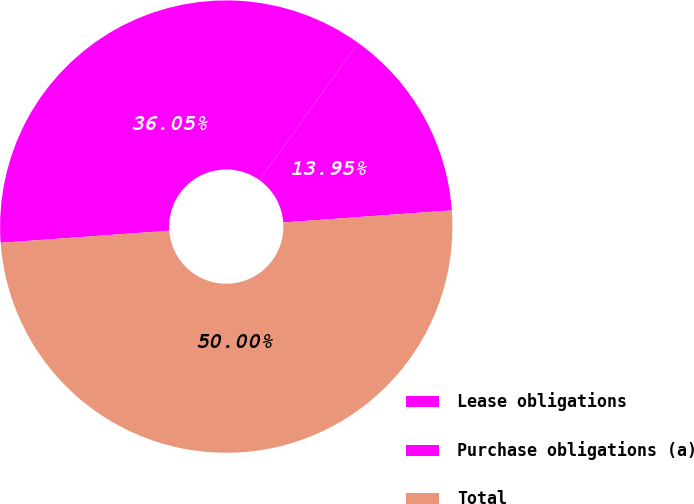Convert chart. <chart><loc_0><loc_0><loc_500><loc_500><pie_chart><fcel>Lease obligations<fcel>Purchase obligations (a)<fcel>Total<nl><fcel>13.95%<fcel>36.05%<fcel>50.0%<nl></chart> 